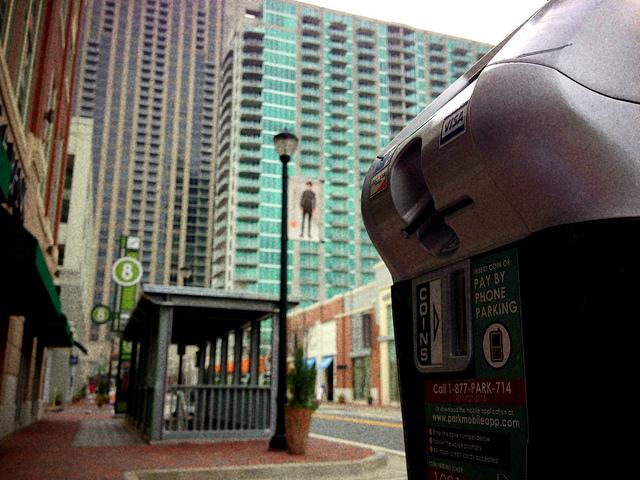Are the buildings in the background tall?
Give a very brief answer. Yes. What number is on the subway sign?
Write a very short answer. 8. What kind of a machine is this?
Quick response, please. Parking meter. 